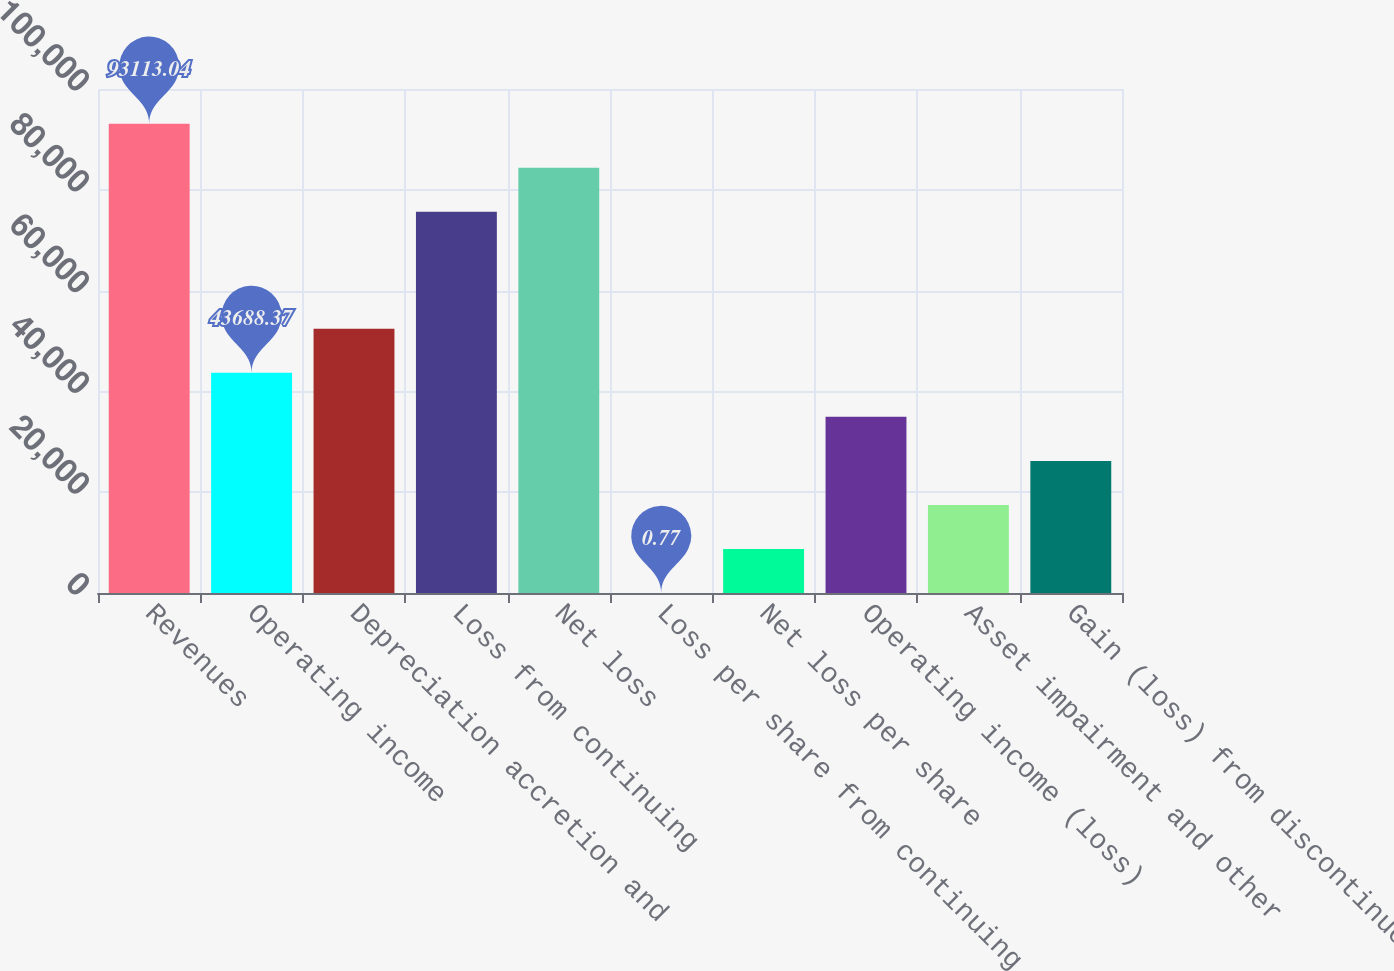<chart> <loc_0><loc_0><loc_500><loc_500><bar_chart><fcel>Revenues<fcel>Operating income<fcel>Depreciation accretion and<fcel>Loss from continuing<fcel>Net loss<fcel>Loss per share from continuing<fcel>Net loss per share<fcel>Operating income (loss)<fcel>Asset impairment and other<fcel>Gain (loss) from discontinued<nl><fcel>93113<fcel>43688.4<fcel>52425.9<fcel>75638<fcel>84375.5<fcel>0.77<fcel>8738.29<fcel>34950.8<fcel>17475.8<fcel>26213.3<nl></chart> 